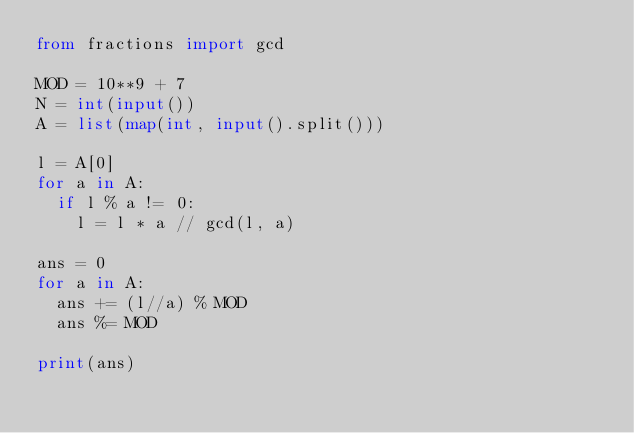<code> <loc_0><loc_0><loc_500><loc_500><_Python_>from fractions import gcd

MOD = 10**9 + 7
N = int(input())
A = list(map(int, input().split()))

l = A[0]
for a in A:
  if l % a != 0:
    l = l * a // gcd(l, a)

ans = 0
for a in A:
  ans += (l//a) % MOD
  ans %= MOD

print(ans)</code> 